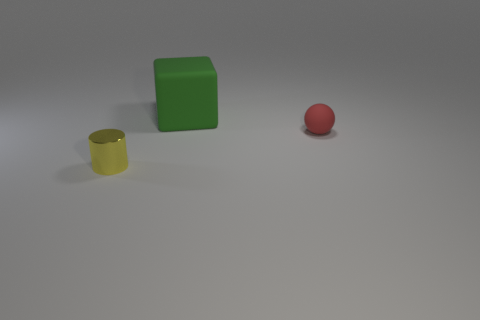Is there a thing of the same color as the small metal cylinder?
Ensure brevity in your answer.  No. What number of other things are there of the same size as the cylinder?
Your answer should be very brief. 1. Is the number of large green cubes that are on the left side of the large thing less than the number of green objects that are behind the metal object?
Offer a terse response. Yes. There is a thing that is both behind the tiny metallic cylinder and to the left of the small red thing; what is its color?
Your answer should be very brief. Green. There is a red rubber thing; is its size the same as the matte object to the left of the tiny sphere?
Your answer should be compact. No. What is the shape of the thing left of the large rubber thing?
Your answer should be compact. Cylinder. Are there any other things that have the same material as the cylinder?
Make the answer very short. No. Are there more small rubber balls that are left of the small yellow thing than spheres?
Offer a very short reply. No. There is a small thing on the right side of the thing that is left of the matte cube; how many small rubber spheres are left of it?
Give a very brief answer. 0. Is the size of the object in front of the tiny matte sphere the same as the rubber object in front of the large green block?
Offer a terse response. Yes. 